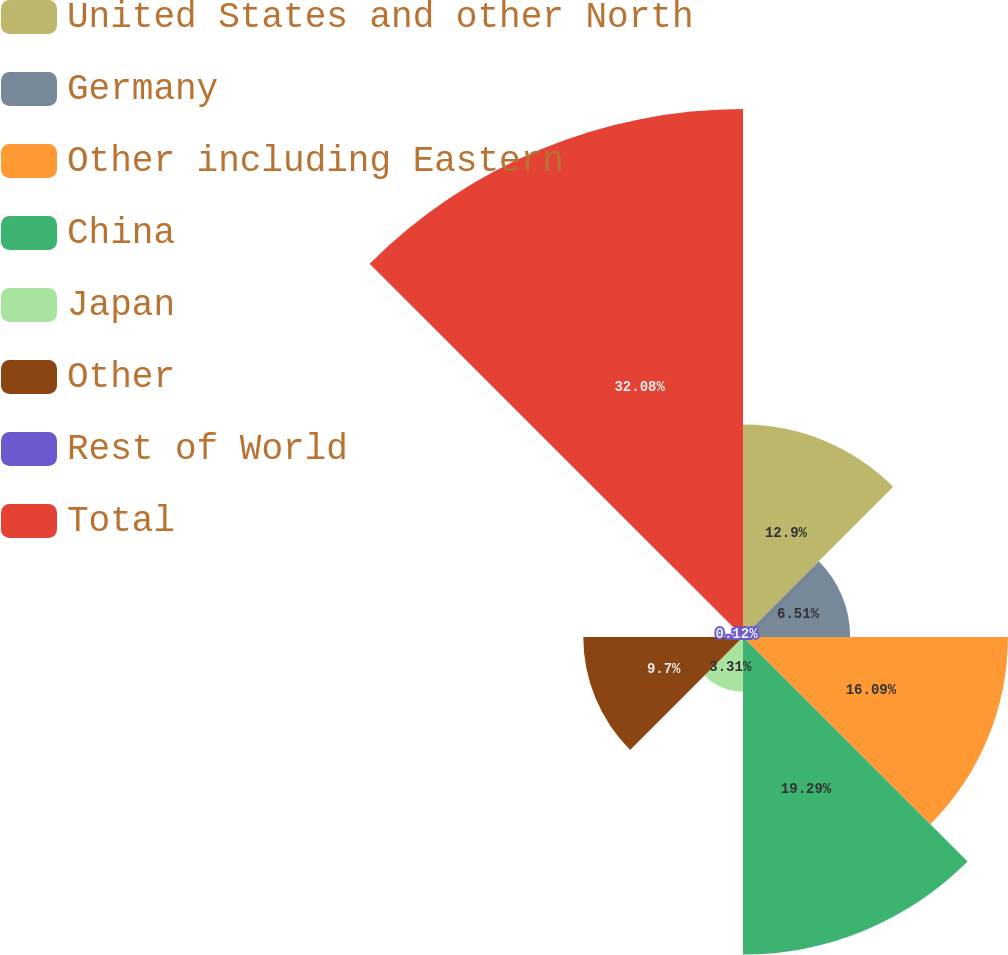<chart> <loc_0><loc_0><loc_500><loc_500><pie_chart><fcel>United States and other North<fcel>Germany<fcel>Other including Eastern<fcel>China<fcel>Japan<fcel>Other<fcel>Rest of World<fcel>Total<nl><fcel>12.9%<fcel>6.51%<fcel>16.09%<fcel>19.29%<fcel>3.31%<fcel>9.7%<fcel>0.12%<fcel>32.07%<nl></chart> 